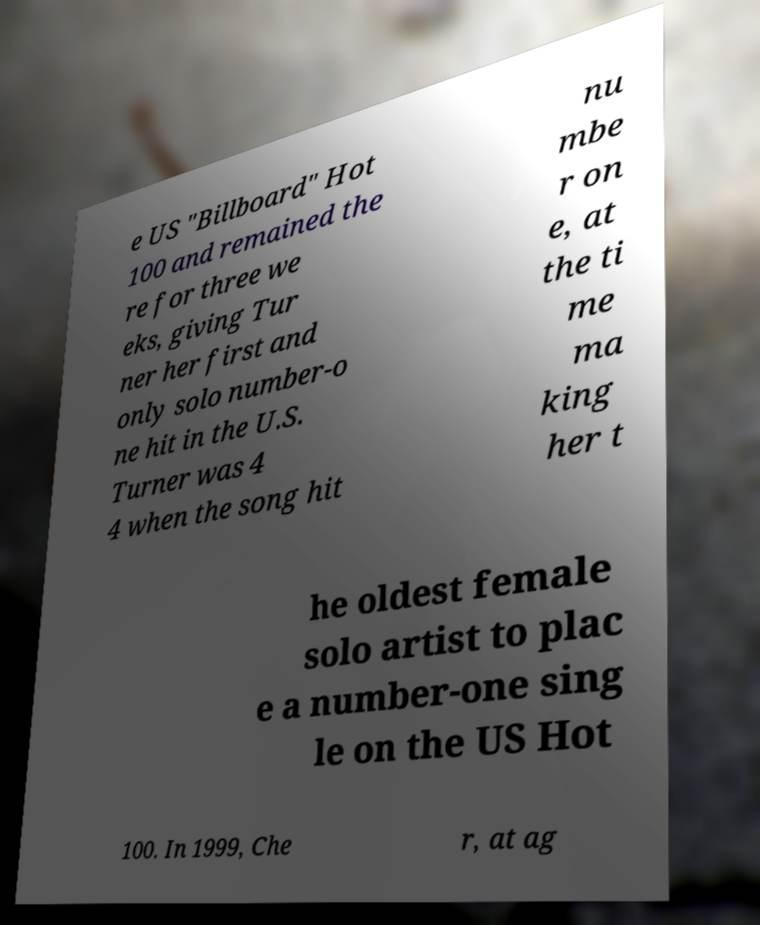Can you read and provide the text displayed in the image?This photo seems to have some interesting text. Can you extract and type it out for me? e US "Billboard" Hot 100 and remained the re for three we eks, giving Tur ner her first and only solo number-o ne hit in the U.S. Turner was 4 4 when the song hit nu mbe r on e, at the ti me ma king her t he oldest female solo artist to plac e a number-one sing le on the US Hot 100. In 1999, Che r, at ag 